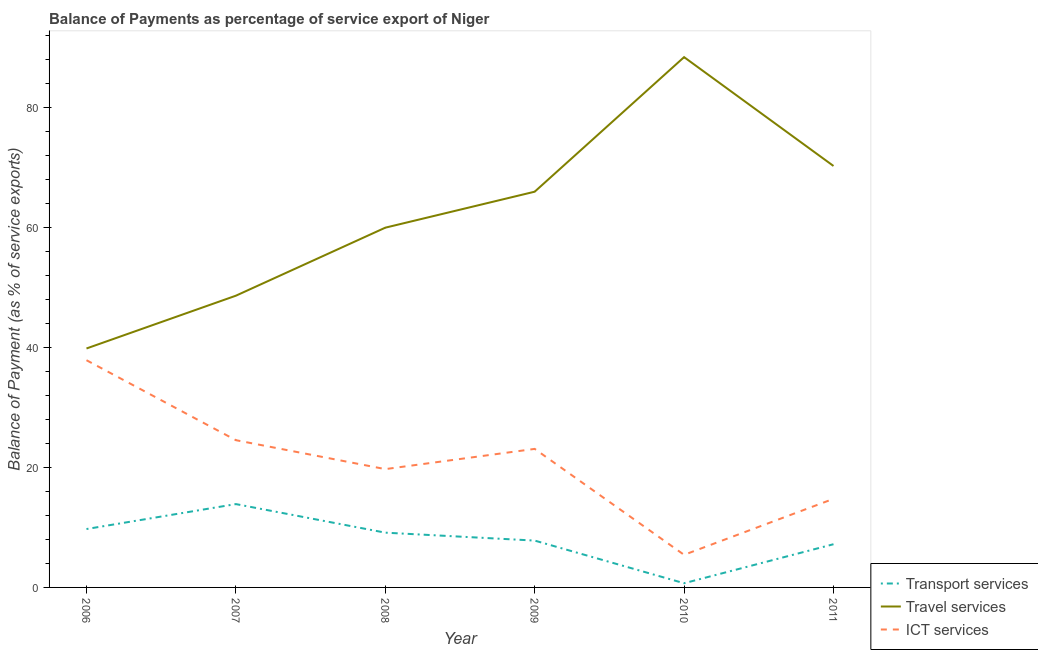Does the line corresponding to balance of payment of transport services intersect with the line corresponding to balance of payment of ict services?
Your answer should be very brief. No. Is the number of lines equal to the number of legend labels?
Offer a very short reply. Yes. What is the balance of payment of ict services in 2008?
Your response must be concise. 19.73. Across all years, what is the maximum balance of payment of ict services?
Offer a very short reply. 37.9. Across all years, what is the minimum balance of payment of ict services?
Offer a terse response. 5.44. In which year was the balance of payment of ict services maximum?
Make the answer very short. 2006. What is the total balance of payment of transport services in the graph?
Your response must be concise. 48.49. What is the difference between the balance of payment of ict services in 2007 and that in 2011?
Provide a succinct answer. 9.78. What is the difference between the balance of payment of ict services in 2010 and the balance of payment of travel services in 2008?
Provide a succinct answer. -54.57. What is the average balance of payment of ict services per year?
Your answer should be very brief. 20.92. In the year 2009, what is the difference between the balance of payment of transport services and balance of payment of ict services?
Make the answer very short. -15.29. What is the ratio of the balance of payment of travel services in 2006 to that in 2011?
Your response must be concise. 0.57. Is the balance of payment of transport services in 2008 less than that in 2011?
Make the answer very short. No. What is the difference between the highest and the second highest balance of payment of travel services?
Your answer should be compact. 18.15. What is the difference between the highest and the lowest balance of payment of ict services?
Offer a terse response. 32.46. Is it the case that in every year, the sum of the balance of payment of transport services and balance of payment of travel services is greater than the balance of payment of ict services?
Your answer should be compact. Yes. Does the balance of payment of ict services monotonically increase over the years?
Your answer should be very brief. No. Is the balance of payment of ict services strictly greater than the balance of payment of travel services over the years?
Offer a terse response. No. Is the balance of payment of transport services strictly less than the balance of payment of travel services over the years?
Offer a terse response. Yes. How many lines are there?
Your answer should be compact. 3. How many years are there in the graph?
Make the answer very short. 6. What is the difference between two consecutive major ticks on the Y-axis?
Give a very brief answer. 20. Are the values on the major ticks of Y-axis written in scientific E-notation?
Give a very brief answer. No. Does the graph contain grids?
Ensure brevity in your answer.  No. How many legend labels are there?
Ensure brevity in your answer.  3. What is the title of the graph?
Ensure brevity in your answer.  Balance of Payments as percentage of service export of Niger. Does "Industry" appear as one of the legend labels in the graph?
Make the answer very short. No. What is the label or title of the Y-axis?
Offer a very short reply. Balance of Payment (as % of service exports). What is the Balance of Payment (as % of service exports) in Transport services in 2006?
Your answer should be compact. 9.74. What is the Balance of Payment (as % of service exports) in Travel services in 2006?
Your answer should be very brief. 39.86. What is the Balance of Payment (as % of service exports) in ICT services in 2006?
Keep it short and to the point. 37.9. What is the Balance of Payment (as % of service exports) of Transport services in 2007?
Provide a short and direct response. 13.9. What is the Balance of Payment (as % of service exports) in Travel services in 2007?
Your response must be concise. 48.66. What is the Balance of Payment (as % of service exports) of ICT services in 2007?
Ensure brevity in your answer.  24.56. What is the Balance of Payment (as % of service exports) in Transport services in 2008?
Offer a very short reply. 9.14. What is the Balance of Payment (as % of service exports) in Travel services in 2008?
Offer a terse response. 60. What is the Balance of Payment (as % of service exports) in ICT services in 2008?
Give a very brief answer. 19.73. What is the Balance of Payment (as % of service exports) in Transport services in 2009?
Offer a very short reply. 7.81. What is the Balance of Payment (as % of service exports) of Travel services in 2009?
Ensure brevity in your answer.  66.01. What is the Balance of Payment (as % of service exports) in ICT services in 2009?
Provide a short and direct response. 23.11. What is the Balance of Payment (as % of service exports) of Transport services in 2010?
Offer a terse response. 0.7. What is the Balance of Payment (as % of service exports) in Travel services in 2010?
Provide a short and direct response. 88.45. What is the Balance of Payment (as % of service exports) of ICT services in 2010?
Provide a succinct answer. 5.44. What is the Balance of Payment (as % of service exports) in Transport services in 2011?
Keep it short and to the point. 7.21. What is the Balance of Payment (as % of service exports) of Travel services in 2011?
Make the answer very short. 70.3. What is the Balance of Payment (as % of service exports) in ICT services in 2011?
Offer a very short reply. 14.78. Across all years, what is the maximum Balance of Payment (as % of service exports) in Transport services?
Keep it short and to the point. 13.9. Across all years, what is the maximum Balance of Payment (as % of service exports) in Travel services?
Your answer should be compact. 88.45. Across all years, what is the maximum Balance of Payment (as % of service exports) of ICT services?
Offer a very short reply. 37.9. Across all years, what is the minimum Balance of Payment (as % of service exports) in Transport services?
Provide a succinct answer. 0.7. Across all years, what is the minimum Balance of Payment (as % of service exports) in Travel services?
Offer a terse response. 39.86. Across all years, what is the minimum Balance of Payment (as % of service exports) in ICT services?
Ensure brevity in your answer.  5.44. What is the total Balance of Payment (as % of service exports) of Transport services in the graph?
Your answer should be compact. 48.49. What is the total Balance of Payment (as % of service exports) of Travel services in the graph?
Offer a very short reply. 373.27. What is the total Balance of Payment (as % of service exports) of ICT services in the graph?
Offer a terse response. 125.51. What is the difference between the Balance of Payment (as % of service exports) of Transport services in 2006 and that in 2007?
Your answer should be compact. -4.16. What is the difference between the Balance of Payment (as % of service exports) of Travel services in 2006 and that in 2007?
Your response must be concise. -8.8. What is the difference between the Balance of Payment (as % of service exports) of ICT services in 2006 and that in 2007?
Make the answer very short. 13.34. What is the difference between the Balance of Payment (as % of service exports) of Transport services in 2006 and that in 2008?
Offer a terse response. 0.6. What is the difference between the Balance of Payment (as % of service exports) in Travel services in 2006 and that in 2008?
Your answer should be compact. -20.15. What is the difference between the Balance of Payment (as % of service exports) in ICT services in 2006 and that in 2008?
Provide a succinct answer. 18.16. What is the difference between the Balance of Payment (as % of service exports) of Transport services in 2006 and that in 2009?
Your response must be concise. 1.93. What is the difference between the Balance of Payment (as % of service exports) in Travel services in 2006 and that in 2009?
Offer a terse response. -26.15. What is the difference between the Balance of Payment (as % of service exports) in ICT services in 2006 and that in 2009?
Offer a very short reply. 14.79. What is the difference between the Balance of Payment (as % of service exports) in Transport services in 2006 and that in 2010?
Your answer should be compact. 9.04. What is the difference between the Balance of Payment (as % of service exports) in Travel services in 2006 and that in 2010?
Your answer should be very brief. -48.6. What is the difference between the Balance of Payment (as % of service exports) of ICT services in 2006 and that in 2010?
Make the answer very short. 32.46. What is the difference between the Balance of Payment (as % of service exports) of Transport services in 2006 and that in 2011?
Ensure brevity in your answer.  2.53. What is the difference between the Balance of Payment (as % of service exports) of Travel services in 2006 and that in 2011?
Your answer should be very brief. -30.44. What is the difference between the Balance of Payment (as % of service exports) of ICT services in 2006 and that in 2011?
Ensure brevity in your answer.  23.12. What is the difference between the Balance of Payment (as % of service exports) in Transport services in 2007 and that in 2008?
Your answer should be compact. 4.76. What is the difference between the Balance of Payment (as % of service exports) of Travel services in 2007 and that in 2008?
Ensure brevity in your answer.  -11.35. What is the difference between the Balance of Payment (as % of service exports) in ICT services in 2007 and that in 2008?
Offer a very short reply. 4.83. What is the difference between the Balance of Payment (as % of service exports) in Transport services in 2007 and that in 2009?
Offer a very short reply. 6.09. What is the difference between the Balance of Payment (as % of service exports) of Travel services in 2007 and that in 2009?
Provide a succinct answer. -17.35. What is the difference between the Balance of Payment (as % of service exports) in ICT services in 2007 and that in 2009?
Your answer should be compact. 1.45. What is the difference between the Balance of Payment (as % of service exports) in Transport services in 2007 and that in 2010?
Give a very brief answer. 13.2. What is the difference between the Balance of Payment (as % of service exports) in Travel services in 2007 and that in 2010?
Keep it short and to the point. -39.79. What is the difference between the Balance of Payment (as % of service exports) in ICT services in 2007 and that in 2010?
Your response must be concise. 19.12. What is the difference between the Balance of Payment (as % of service exports) of Transport services in 2007 and that in 2011?
Provide a succinct answer. 6.69. What is the difference between the Balance of Payment (as % of service exports) of Travel services in 2007 and that in 2011?
Make the answer very short. -21.64. What is the difference between the Balance of Payment (as % of service exports) in ICT services in 2007 and that in 2011?
Make the answer very short. 9.78. What is the difference between the Balance of Payment (as % of service exports) in Transport services in 2008 and that in 2009?
Your answer should be compact. 1.32. What is the difference between the Balance of Payment (as % of service exports) in Travel services in 2008 and that in 2009?
Provide a succinct answer. -6. What is the difference between the Balance of Payment (as % of service exports) of ICT services in 2008 and that in 2009?
Give a very brief answer. -3.37. What is the difference between the Balance of Payment (as % of service exports) in Transport services in 2008 and that in 2010?
Offer a terse response. 8.44. What is the difference between the Balance of Payment (as % of service exports) of Travel services in 2008 and that in 2010?
Offer a very short reply. -28.45. What is the difference between the Balance of Payment (as % of service exports) in ICT services in 2008 and that in 2010?
Provide a short and direct response. 14.3. What is the difference between the Balance of Payment (as % of service exports) of Transport services in 2008 and that in 2011?
Give a very brief answer. 1.93. What is the difference between the Balance of Payment (as % of service exports) in Travel services in 2008 and that in 2011?
Offer a very short reply. -10.29. What is the difference between the Balance of Payment (as % of service exports) of ICT services in 2008 and that in 2011?
Your answer should be very brief. 4.95. What is the difference between the Balance of Payment (as % of service exports) in Transport services in 2009 and that in 2010?
Offer a terse response. 7.11. What is the difference between the Balance of Payment (as % of service exports) of Travel services in 2009 and that in 2010?
Offer a very short reply. -22.44. What is the difference between the Balance of Payment (as % of service exports) of ICT services in 2009 and that in 2010?
Your response must be concise. 17.67. What is the difference between the Balance of Payment (as % of service exports) of Transport services in 2009 and that in 2011?
Your response must be concise. 0.61. What is the difference between the Balance of Payment (as % of service exports) of Travel services in 2009 and that in 2011?
Your answer should be compact. -4.29. What is the difference between the Balance of Payment (as % of service exports) of ICT services in 2009 and that in 2011?
Provide a succinct answer. 8.33. What is the difference between the Balance of Payment (as % of service exports) in Transport services in 2010 and that in 2011?
Provide a succinct answer. -6.51. What is the difference between the Balance of Payment (as % of service exports) of Travel services in 2010 and that in 2011?
Offer a terse response. 18.15. What is the difference between the Balance of Payment (as % of service exports) of ICT services in 2010 and that in 2011?
Ensure brevity in your answer.  -9.34. What is the difference between the Balance of Payment (as % of service exports) in Transport services in 2006 and the Balance of Payment (as % of service exports) in Travel services in 2007?
Keep it short and to the point. -38.92. What is the difference between the Balance of Payment (as % of service exports) of Transport services in 2006 and the Balance of Payment (as % of service exports) of ICT services in 2007?
Your answer should be very brief. -14.82. What is the difference between the Balance of Payment (as % of service exports) of Travel services in 2006 and the Balance of Payment (as % of service exports) of ICT services in 2007?
Provide a succinct answer. 15.3. What is the difference between the Balance of Payment (as % of service exports) in Transport services in 2006 and the Balance of Payment (as % of service exports) in Travel services in 2008?
Ensure brevity in your answer.  -50.26. What is the difference between the Balance of Payment (as % of service exports) in Transport services in 2006 and the Balance of Payment (as % of service exports) in ICT services in 2008?
Offer a very short reply. -9.99. What is the difference between the Balance of Payment (as % of service exports) in Travel services in 2006 and the Balance of Payment (as % of service exports) in ICT services in 2008?
Provide a succinct answer. 20.12. What is the difference between the Balance of Payment (as % of service exports) in Transport services in 2006 and the Balance of Payment (as % of service exports) in Travel services in 2009?
Your response must be concise. -56.27. What is the difference between the Balance of Payment (as % of service exports) in Transport services in 2006 and the Balance of Payment (as % of service exports) in ICT services in 2009?
Ensure brevity in your answer.  -13.37. What is the difference between the Balance of Payment (as % of service exports) of Travel services in 2006 and the Balance of Payment (as % of service exports) of ICT services in 2009?
Your response must be concise. 16.75. What is the difference between the Balance of Payment (as % of service exports) in Transport services in 2006 and the Balance of Payment (as % of service exports) in Travel services in 2010?
Your response must be concise. -78.71. What is the difference between the Balance of Payment (as % of service exports) in Transport services in 2006 and the Balance of Payment (as % of service exports) in ICT services in 2010?
Your answer should be very brief. 4.3. What is the difference between the Balance of Payment (as % of service exports) of Travel services in 2006 and the Balance of Payment (as % of service exports) of ICT services in 2010?
Make the answer very short. 34.42. What is the difference between the Balance of Payment (as % of service exports) in Transport services in 2006 and the Balance of Payment (as % of service exports) in Travel services in 2011?
Offer a terse response. -60.56. What is the difference between the Balance of Payment (as % of service exports) of Transport services in 2006 and the Balance of Payment (as % of service exports) of ICT services in 2011?
Provide a succinct answer. -5.04. What is the difference between the Balance of Payment (as % of service exports) of Travel services in 2006 and the Balance of Payment (as % of service exports) of ICT services in 2011?
Give a very brief answer. 25.08. What is the difference between the Balance of Payment (as % of service exports) of Transport services in 2007 and the Balance of Payment (as % of service exports) of Travel services in 2008?
Offer a terse response. -46.1. What is the difference between the Balance of Payment (as % of service exports) of Transport services in 2007 and the Balance of Payment (as % of service exports) of ICT services in 2008?
Ensure brevity in your answer.  -5.83. What is the difference between the Balance of Payment (as % of service exports) in Travel services in 2007 and the Balance of Payment (as % of service exports) in ICT services in 2008?
Provide a succinct answer. 28.93. What is the difference between the Balance of Payment (as % of service exports) in Transport services in 2007 and the Balance of Payment (as % of service exports) in Travel services in 2009?
Offer a very short reply. -52.11. What is the difference between the Balance of Payment (as % of service exports) of Transport services in 2007 and the Balance of Payment (as % of service exports) of ICT services in 2009?
Provide a short and direct response. -9.21. What is the difference between the Balance of Payment (as % of service exports) in Travel services in 2007 and the Balance of Payment (as % of service exports) in ICT services in 2009?
Provide a succinct answer. 25.55. What is the difference between the Balance of Payment (as % of service exports) in Transport services in 2007 and the Balance of Payment (as % of service exports) in Travel services in 2010?
Ensure brevity in your answer.  -74.55. What is the difference between the Balance of Payment (as % of service exports) of Transport services in 2007 and the Balance of Payment (as % of service exports) of ICT services in 2010?
Provide a short and direct response. 8.46. What is the difference between the Balance of Payment (as % of service exports) of Travel services in 2007 and the Balance of Payment (as % of service exports) of ICT services in 2010?
Your answer should be compact. 43.22. What is the difference between the Balance of Payment (as % of service exports) in Transport services in 2007 and the Balance of Payment (as % of service exports) in Travel services in 2011?
Ensure brevity in your answer.  -56.4. What is the difference between the Balance of Payment (as % of service exports) of Transport services in 2007 and the Balance of Payment (as % of service exports) of ICT services in 2011?
Ensure brevity in your answer.  -0.88. What is the difference between the Balance of Payment (as % of service exports) of Travel services in 2007 and the Balance of Payment (as % of service exports) of ICT services in 2011?
Keep it short and to the point. 33.88. What is the difference between the Balance of Payment (as % of service exports) in Transport services in 2008 and the Balance of Payment (as % of service exports) in Travel services in 2009?
Provide a short and direct response. -56.87. What is the difference between the Balance of Payment (as % of service exports) in Transport services in 2008 and the Balance of Payment (as % of service exports) in ICT services in 2009?
Keep it short and to the point. -13.97. What is the difference between the Balance of Payment (as % of service exports) of Travel services in 2008 and the Balance of Payment (as % of service exports) of ICT services in 2009?
Your answer should be very brief. 36.9. What is the difference between the Balance of Payment (as % of service exports) in Transport services in 2008 and the Balance of Payment (as % of service exports) in Travel services in 2010?
Provide a succinct answer. -79.32. What is the difference between the Balance of Payment (as % of service exports) of Transport services in 2008 and the Balance of Payment (as % of service exports) of ICT services in 2010?
Your answer should be compact. 3.7. What is the difference between the Balance of Payment (as % of service exports) in Travel services in 2008 and the Balance of Payment (as % of service exports) in ICT services in 2010?
Your answer should be compact. 54.57. What is the difference between the Balance of Payment (as % of service exports) of Transport services in 2008 and the Balance of Payment (as % of service exports) of Travel services in 2011?
Make the answer very short. -61.16. What is the difference between the Balance of Payment (as % of service exports) in Transport services in 2008 and the Balance of Payment (as % of service exports) in ICT services in 2011?
Ensure brevity in your answer.  -5.64. What is the difference between the Balance of Payment (as % of service exports) of Travel services in 2008 and the Balance of Payment (as % of service exports) of ICT services in 2011?
Your response must be concise. 45.23. What is the difference between the Balance of Payment (as % of service exports) in Transport services in 2009 and the Balance of Payment (as % of service exports) in Travel services in 2010?
Give a very brief answer. -80.64. What is the difference between the Balance of Payment (as % of service exports) in Transport services in 2009 and the Balance of Payment (as % of service exports) in ICT services in 2010?
Provide a short and direct response. 2.37. What is the difference between the Balance of Payment (as % of service exports) of Travel services in 2009 and the Balance of Payment (as % of service exports) of ICT services in 2010?
Ensure brevity in your answer.  60.57. What is the difference between the Balance of Payment (as % of service exports) of Transport services in 2009 and the Balance of Payment (as % of service exports) of Travel services in 2011?
Provide a short and direct response. -62.48. What is the difference between the Balance of Payment (as % of service exports) of Transport services in 2009 and the Balance of Payment (as % of service exports) of ICT services in 2011?
Provide a short and direct response. -6.97. What is the difference between the Balance of Payment (as % of service exports) in Travel services in 2009 and the Balance of Payment (as % of service exports) in ICT services in 2011?
Your answer should be compact. 51.23. What is the difference between the Balance of Payment (as % of service exports) in Transport services in 2010 and the Balance of Payment (as % of service exports) in Travel services in 2011?
Ensure brevity in your answer.  -69.6. What is the difference between the Balance of Payment (as % of service exports) of Transport services in 2010 and the Balance of Payment (as % of service exports) of ICT services in 2011?
Keep it short and to the point. -14.08. What is the difference between the Balance of Payment (as % of service exports) of Travel services in 2010 and the Balance of Payment (as % of service exports) of ICT services in 2011?
Your answer should be compact. 73.67. What is the average Balance of Payment (as % of service exports) in Transport services per year?
Offer a terse response. 8.08. What is the average Balance of Payment (as % of service exports) of Travel services per year?
Keep it short and to the point. 62.21. What is the average Balance of Payment (as % of service exports) in ICT services per year?
Keep it short and to the point. 20.92. In the year 2006, what is the difference between the Balance of Payment (as % of service exports) in Transport services and Balance of Payment (as % of service exports) in Travel services?
Your answer should be compact. -30.12. In the year 2006, what is the difference between the Balance of Payment (as % of service exports) of Transport services and Balance of Payment (as % of service exports) of ICT services?
Make the answer very short. -28.16. In the year 2006, what is the difference between the Balance of Payment (as % of service exports) of Travel services and Balance of Payment (as % of service exports) of ICT services?
Give a very brief answer. 1.96. In the year 2007, what is the difference between the Balance of Payment (as % of service exports) of Transport services and Balance of Payment (as % of service exports) of Travel services?
Ensure brevity in your answer.  -34.76. In the year 2007, what is the difference between the Balance of Payment (as % of service exports) in Transport services and Balance of Payment (as % of service exports) in ICT services?
Ensure brevity in your answer.  -10.66. In the year 2007, what is the difference between the Balance of Payment (as % of service exports) in Travel services and Balance of Payment (as % of service exports) in ICT services?
Make the answer very short. 24.1. In the year 2008, what is the difference between the Balance of Payment (as % of service exports) of Transport services and Balance of Payment (as % of service exports) of Travel services?
Provide a succinct answer. -50.87. In the year 2008, what is the difference between the Balance of Payment (as % of service exports) in Transport services and Balance of Payment (as % of service exports) in ICT services?
Offer a terse response. -10.6. In the year 2008, what is the difference between the Balance of Payment (as % of service exports) in Travel services and Balance of Payment (as % of service exports) in ICT services?
Offer a terse response. 40.27. In the year 2009, what is the difference between the Balance of Payment (as % of service exports) in Transport services and Balance of Payment (as % of service exports) in Travel services?
Provide a succinct answer. -58.19. In the year 2009, what is the difference between the Balance of Payment (as % of service exports) in Transport services and Balance of Payment (as % of service exports) in ICT services?
Keep it short and to the point. -15.29. In the year 2009, what is the difference between the Balance of Payment (as % of service exports) of Travel services and Balance of Payment (as % of service exports) of ICT services?
Make the answer very short. 42.9. In the year 2010, what is the difference between the Balance of Payment (as % of service exports) of Transport services and Balance of Payment (as % of service exports) of Travel services?
Ensure brevity in your answer.  -87.75. In the year 2010, what is the difference between the Balance of Payment (as % of service exports) in Transport services and Balance of Payment (as % of service exports) in ICT services?
Ensure brevity in your answer.  -4.74. In the year 2010, what is the difference between the Balance of Payment (as % of service exports) of Travel services and Balance of Payment (as % of service exports) of ICT services?
Make the answer very short. 83.01. In the year 2011, what is the difference between the Balance of Payment (as % of service exports) of Transport services and Balance of Payment (as % of service exports) of Travel services?
Offer a very short reply. -63.09. In the year 2011, what is the difference between the Balance of Payment (as % of service exports) of Transport services and Balance of Payment (as % of service exports) of ICT services?
Offer a very short reply. -7.57. In the year 2011, what is the difference between the Balance of Payment (as % of service exports) in Travel services and Balance of Payment (as % of service exports) in ICT services?
Provide a succinct answer. 55.52. What is the ratio of the Balance of Payment (as % of service exports) in Transport services in 2006 to that in 2007?
Ensure brevity in your answer.  0.7. What is the ratio of the Balance of Payment (as % of service exports) in Travel services in 2006 to that in 2007?
Give a very brief answer. 0.82. What is the ratio of the Balance of Payment (as % of service exports) of ICT services in 2006 to that in 2007?
Ensure brevity in your answer.  1.54. What is the ratio of the Balance of Payment (as % of service exports) of Transport services in 2006 to that in 2008?
Make the answer very short. 1.07. What is the ratio of the Balance of Payment (as % of service exports) in Travel services in 2006 to that in 2008?
Ensure brevity in your answer.  0.66. What is the ratio of the Balance of Payment (as % of service exports) in ICT services in 2006 to that in 2008?
Your answer should be compact. 1.92. What is the ratio of the Balance of Payment (as % of service exports) of Transport services in 2006 to that in 2009?
Offer a terse response. 1.25. What is the ratio of the Balance of Payment (as % of service exports) in Travel services in 2006 to that in 2009?
Provide a succinct answer. 0.6. What is the ratio of the Balance of Payment (as % of service exports) of ICT services in 2006 to that in 2009?
Your response must be concise. 1.64. What is the ratio of the Balance of Payment (as % of service exports) in Transport services in 2006 to that in 2010?
Make the answer very short. 13.94. What is the ratio of the Balance of Payment (as % of service exports) in Travel services in 2006 to that in 2010?
Your answer should be very brief. 0.45. What is the ratio of the Balance of Payment (as % of service exports) in ICT services in 2006 to that in 2010?
Ensure brevity in your answer.  6.97. What is the ratio of the Balance of Payment (as % of service exports) of Transport services in 2006 to that in 2011?
Your answer should be compact. 1.35. What is the ratio of the Balance of Payment (as % of service exports) in Travel services in 2006 to that in 2011?
Keep it short and to the point. 0.57. What is the ratio of the Balance of Payment (as % of service exports) in ICT services in 2006 to that in 2011?
Give a very brief answer. 2.56. What is the ratio of the Balance of Payment (as % of service exports) of Transport services in 2007 to that in 2008?
Your response must be concise. 1.52. What is the ratio of the Balance of Payment (as % of service exports) in Travel services in 2007 to that in 2008?
Your answer should be compact. 0.81. What is the ratio of the Balance of Payment (as % of service exports) of ICT services in 2007 to that in 2008?
Offer a very short reply. 1.24. What is the ratio of the Balance of Payment (as % of service exports) of Transport services in 2007 to that in 2009?
Offer a very short reply. 1.78. What is the ratio of the Balance of Payment (as % of service exports) in Travel services in 2007 to that in 2009?
Offer a very short reply. 0.74. What is the ratio of the Balance of Payment (as % of service exports) in ICT services in 2007 to that in 2009?
Your answer should be very brief. 1.06. What is the ratio of the Balance of Payment (as % of service exports) of Transport services in 2007 to that in 2010?
Give a very brief answer. 19.89. What is the ratio of the Balance of Payment (as % of service exports) in Travel services in 2007 to that in 2010?
Your answer should be compact. 0.55. What is the ratio of the Balance of Payment (as % of service exports) of ICT services in 2007 to that in 2010?
Your answer should be very brief. 4.52. What is the ratio of the Balance of Payment (as % of service exports) of Transport services in 2007 to that in 2011?
Your response must be concise. 1.93. What is the ratio of the Balance of Payment (as % of service exports) in Travel services in 2007 to that in 2011?
Your answer should be compact. 0.69. What is the ratio of the Balance of Payment (as % of service exports) of ICT services in 2007 to that in 2011?
Keep it short and to the point. 1.66. What is the ratio of the Balance of Payment (as % of service exports) of Transport services in 2008 to that in 2009?
Provide a succinct answer. 1.17. What is the ratio of the Balance of Payment (as % of service exports) of Travel services in 2008 to that in 2009?
Offer a terse response. 0.91. What is the ratio of the Balance of Payment (as % of service exports) of ICT services in 2008 to that in 2009?
Make the answer very short. 0.85. What is the ratio of the Balance of Payment (as % of service exports) in Transport services in 2008 to that in 2010?
Give a very brief answer. 13.07. What is the ratio of the Balance of Payment (as % of service exports) of Travel services in 2008 to that in 2010?
Make the answer very short. 0.68. What is the ratio of the Balance of Payment (as % of service exports) in ICT services in 2008 to that in 2010?
Provide a succinct answer. 3.63. What is the ratio of the Balance of Payment (as % of service exports) of Transport services in 2008 to that in 2011?
Ensure brevity in your answer.  1.27. What is the ratio of the Balance of Payment (as % of service exports) of Travel services in 2008 to that in 2011?
Give a very brief answer. 0.85. What is the ratio of the Balance of Payment (as % of service exports) in ICT services in 2008 to that in 2011?
Offer a terse response. 1.34. What is the ratio of the Balance of Payment (as % of service exports) in Transport services in 2009 to that in 2010?
Make the answer very short. 11.18. What is the ratio of the Balance of Payment (as % of service exports) in Travel services in 2009 to that in 2010?
Provide a succinct answer. 0.75. What is the ratio of the Balance of Payment (as % of service exports) in ICT services in 2009 to that in 2010?
Offer a very short reply. 4.25. What is the ratio of the Balance of Payment (as % of service exports) of Transport services in 2009 to that in 2011?
Your response must be concise. 1.08. What is the ratio of the Balance of Payment (as % of service exports) in Travel services in 2009 to that in 2011?
Provide a succinct answer. 0.94. What is the ratio of the Balance of Payment (as % of service exports) of ICT services in 2009 to that in 2011?
Provide a succinct answer. 1.56. What is the ratio of the Balance of Payment (as % of service exports) of Transport services in 2010 to that in 2011?
Your answer should be compact. 0.1. What is the ratio of the Balance of Payment (as % of service exports) in Travel services in 2010 to that in 2011?
Offer a very short reply. 1.26. What is the ratio of the Balance of Payment (as % of service exports) in ICT services in 2010 to that in 2011?
Offer a terse response. 0.37. What is the difference between the highest and the second highest Balance of Payment (as % of service exports) in Transport services?
Your answer should be compact. 4.16. What is the difference between the highest and the second highest Balance of Payment (as % of service exports) in Travel services?
Ensure brevity in your answer.  18.15. What is the difference between the highest and the second highest Balance of Payment (as % of service exports) of ICT services?
Offer a terse response. 13.34. What is the difference between the highest and the lowest Balance of Payment (as % of service exports) of Transport services?
Provide a short and direct response. 13.2. What is the difference between the highest and the lowest Balance of Payment (as % of service exports) in Travel services?
Make the answer very short. 48.6. What is the difference between the highest and the lowest Balance of Payment (as % of service exports) in ICT services?
Provide a succinct answer. 32.46. 